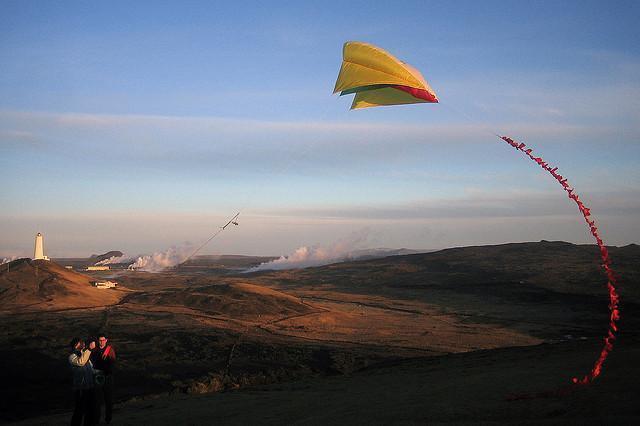How many people are flying the kite?
Give a very brief answer. 2. 